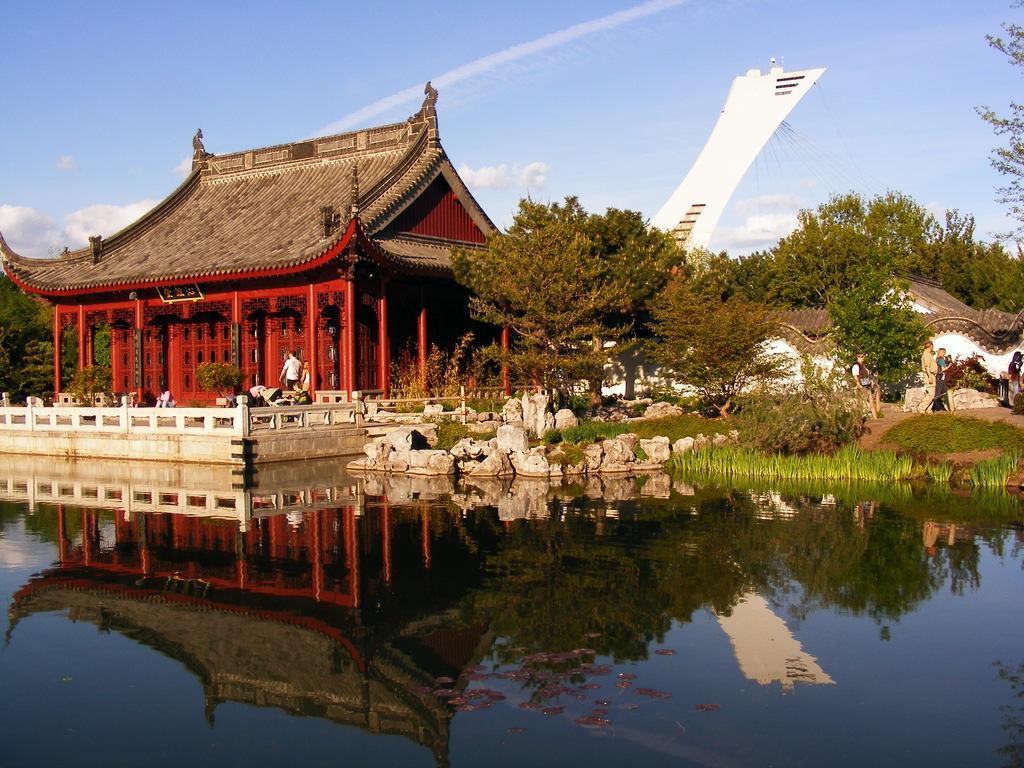How would you summarize this image in a sentence or two? In this image, in the middle there is a house. At the bottom there are stones, plants, grass, water. In the middle there are people, trees, sky and clouds. 